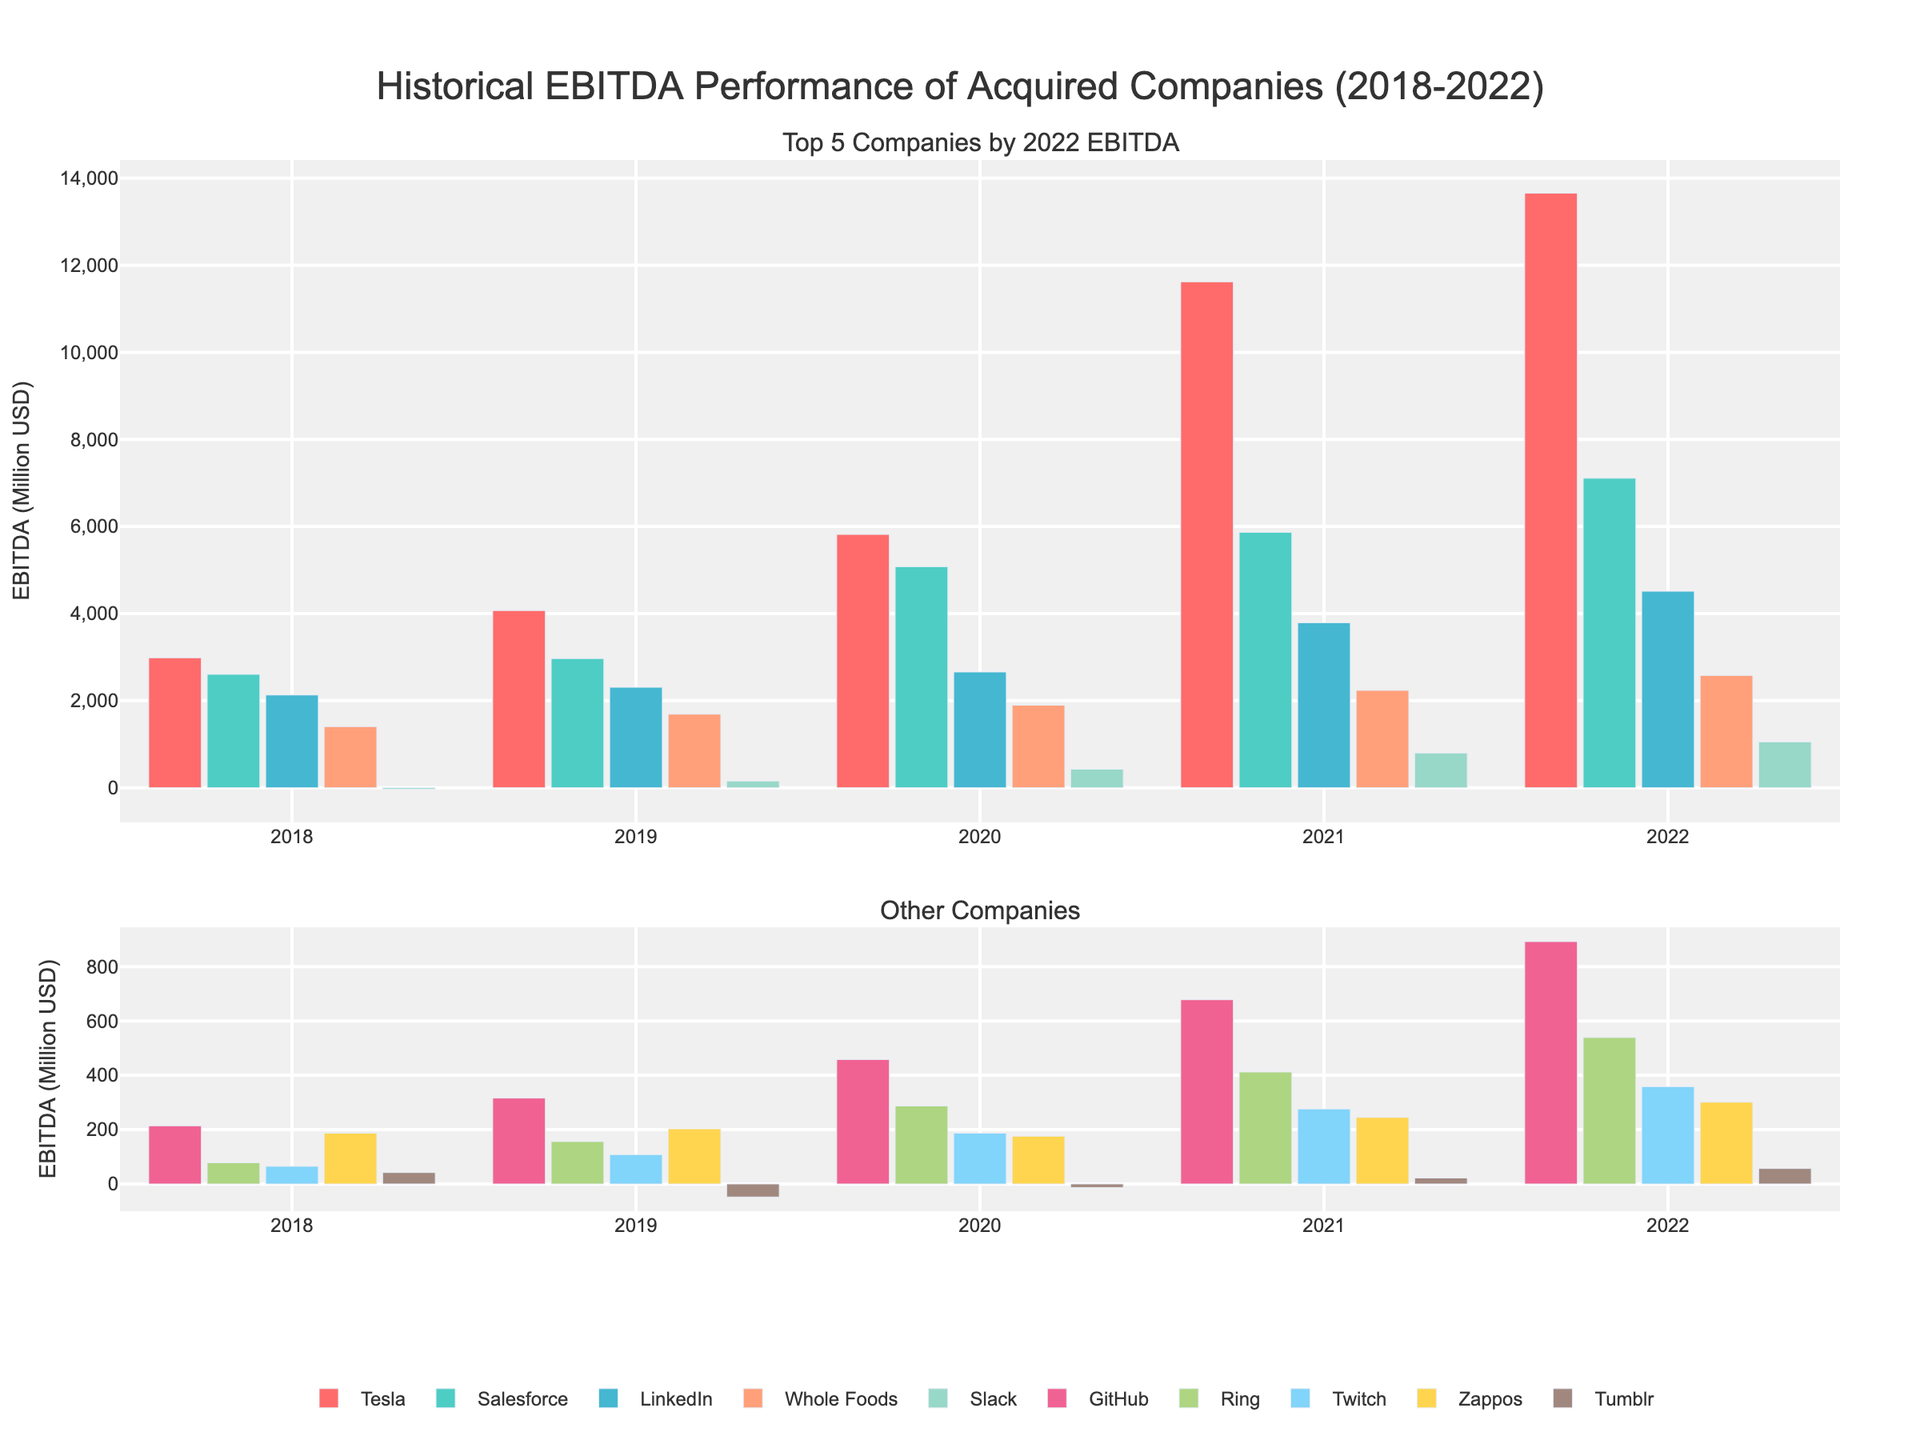What was the EBITDA of Tesla in 2020, and how does it compare to its EBITDA in 2019? Tesla’s EBITDA in 2020 was 5817 and in 2019 it was 4069. To compare, we subtract the 2019 figure from the 2020 figure: 5817 - 4069 = 1748. Tesla's EBITDA increased by 1748 from 2019 to 2020.
Answer: 1748 Which company had the highest EBITDA in 2022, and what was the amount? Looking at the bar height in the 2022 column, Tesla has the tallest bar. The numeric label indicates Tesla’s EBITDA in 2022 was 13656.
Answer: Tesla, 13656 Compare the EBITDA growth of Whole Foods and LinkedIn from 2018 to 2022. Which company had higher growth and by how much? Whole Foods’ EBITDA in 2018 was 1403 and 2578 in 2022, resulting in a growth of 1175 (2578 - 1403). LinkedIn’s EBITDA in 2018 was 2129 and 4512 in 2022, resulting in a growth of 2383 (4512 - 2129). To compare, 2383 - 1175 = 1208. LinkedIn grew more by 1208.
Answer: LinkedIn, 1208 Between 2019 and 2020, which company had the highest percentage increase in EBITDA? We need EBITDA values for 2019 and 2020 for all companies. Percentage increase = ( (2020 value - 2019 value) / 2019 value ) * 100. We do this for each, finding Tesla: ((5817 - 4069) / 4069) * 100 ≈ 42.98%, Salesforce: ((5076 - 2966) / 2966) * 100 ≈ 71.13%, LinkedIn: ((2658 - 2307) / 2307) * 100 ≈ 15.20%, Whole Foods: ((1894 - 1688) / 1688) * 100 ≈ 12.21%, etc. Salesforce has the highest percentage increase.
Answer: Salesforce Which company consistently increased its EBITDA every year from 2018 to 2022? By visually inspecting the bars for each company across all years, we note that Tesla, Salesforce, LinkedIn, Whole Foods, Slack, GitHub, Ring, Twitch consistently increased their EBITDA every year without any year showing a decline. A deeper examination confirms these.
Answer: Tesla, Salesforce, LinkedIn, Whole Foods, Slack, GitHub, Ring, Twitch What is the average EBITDA of Salesforce from 2018 to 2022? Sum of Salesforce’s EBITDA from 2018 to 2022: 2604 + 2966 + 5076 + 5865 + 7107 = 23618. Average = 23618 / 5 = 4723.6.
Answer: 4724 How did the EBITDA of Tumblr change from 2018 to 2022? Tumblr's EBITDA for 2018 is 42 and for 2022 is 57. The change is calculated by 57 - 42 = 15. So, Tumblr’s EBITDA increased by 15 from 2018 to 2022.
Answer: 15 Which company had the smallest EBITDA in 2021 and what was the amount? By observing the bar heights in 2021, Tumblr has the smallest bar. Numeric inspection verifies that Tumblr’s EBITDA in 2021 was 22.
Answer: Tumblr, 22 Calculate the total EBITDA for Twitch from 2018 to 2022. Sum of Twitch’s EBITDA from 2018 to 2022: 65 + 108 + 187 + 276 + 358 = 994.
Answer: 994 